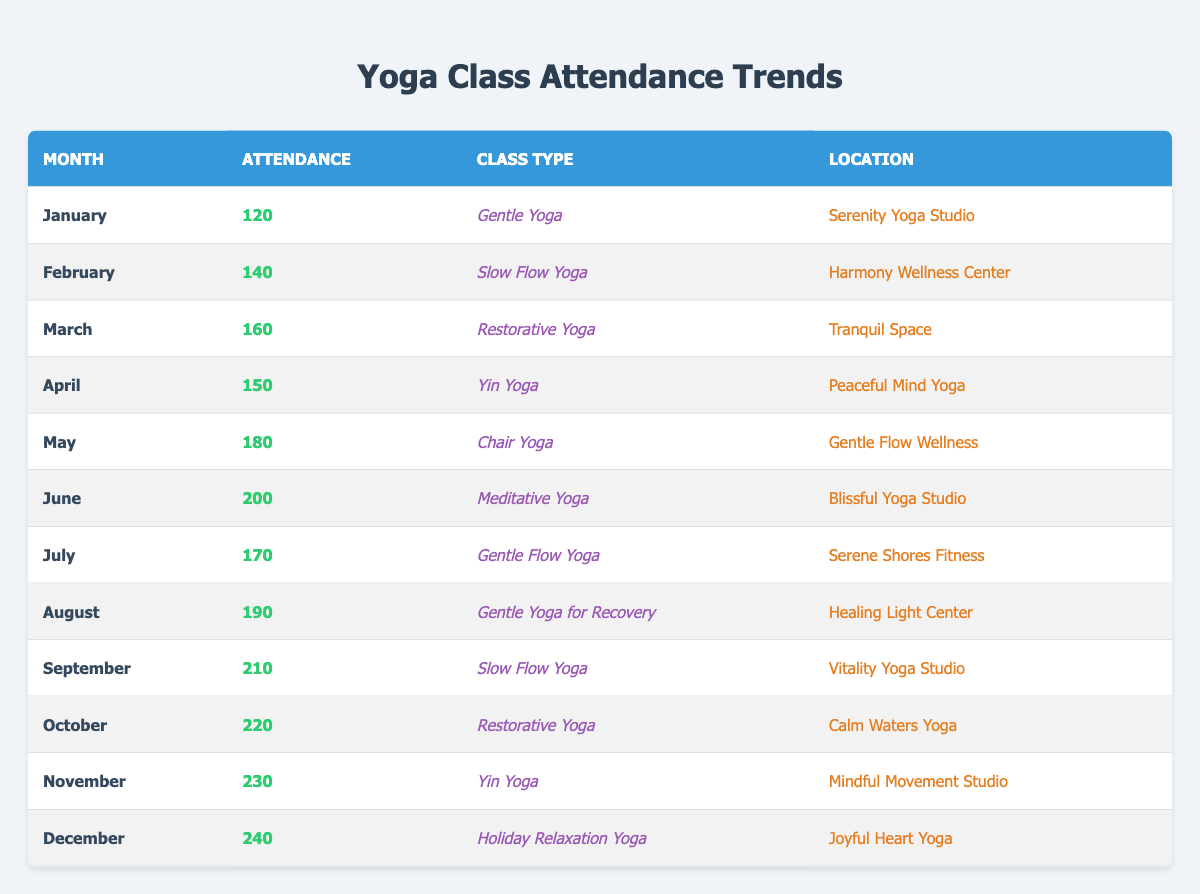What was the highest attendance recorded in a month? The month with the highest attendance is December, which recorded 240 attendees. This can be seen by comparing the attendance numbers listed for each month.
Answer: 240 Which month had the lowest attendance? January had the lowest attendance with 120 attendees. This is determined by looking at the attendance values for each month and identifying the smallest number.
Answer: 120 What is the average attendance for the months of June to August? The attendances for June (200), July (170), and August (190) total to 560. To find the average, divide the total attendance by the number of months, resulting in 560/3 = 186.67.
Answer: 186.67 Did attendance generally increase over the months? Yes, attendance increased over the months, especially from January (120) to December (240). By checking the values chronologically, we can observe a consistent upward trend in attendance numbers.
Answer: Yes Which location had the highest attendance for its yoga class? The location with the highest attendance is Joyful Heart Yoga in December, with 240 attendees. This can be verified by examining the attendance numbers and their corresponding locations in the table.
Answer: Joyful Heart Yoga What is the total attendance from May to September? The attendances for May (180), June (200), July (170), August (190), and September (210) total to 1,150. This is calculated by summing these values: 180 + 200 + 170 + 190 + 210 = 1,150.
Answer: 1150 How many months had more than 200 attendees? There are three months with more than 200 attendees: October (220), November (230), and December (240). This is determined by counting the months where attendance exceeds 200.
Answer: 3 What type of yoga class had the highest attendance and in which month? The Yoga class with the highest attendance was Holiday Relaxation Yoga in December with 240 attendees. This can be confirmed by reviewing the attendance values and matching them with the class types and months.
Answer: Holiday Relaxation Yoga, December Is the attendance for Gentle Yoga in January higher than for Slow Flow Yoga in February? No, the attendance for Gentle Yoga in January is 120, which is lower than Slow Flow Yoga in February with an attendance of 140. This comparison is straightforward as it involves looking at the two specific attendance figures.
Answer: No 